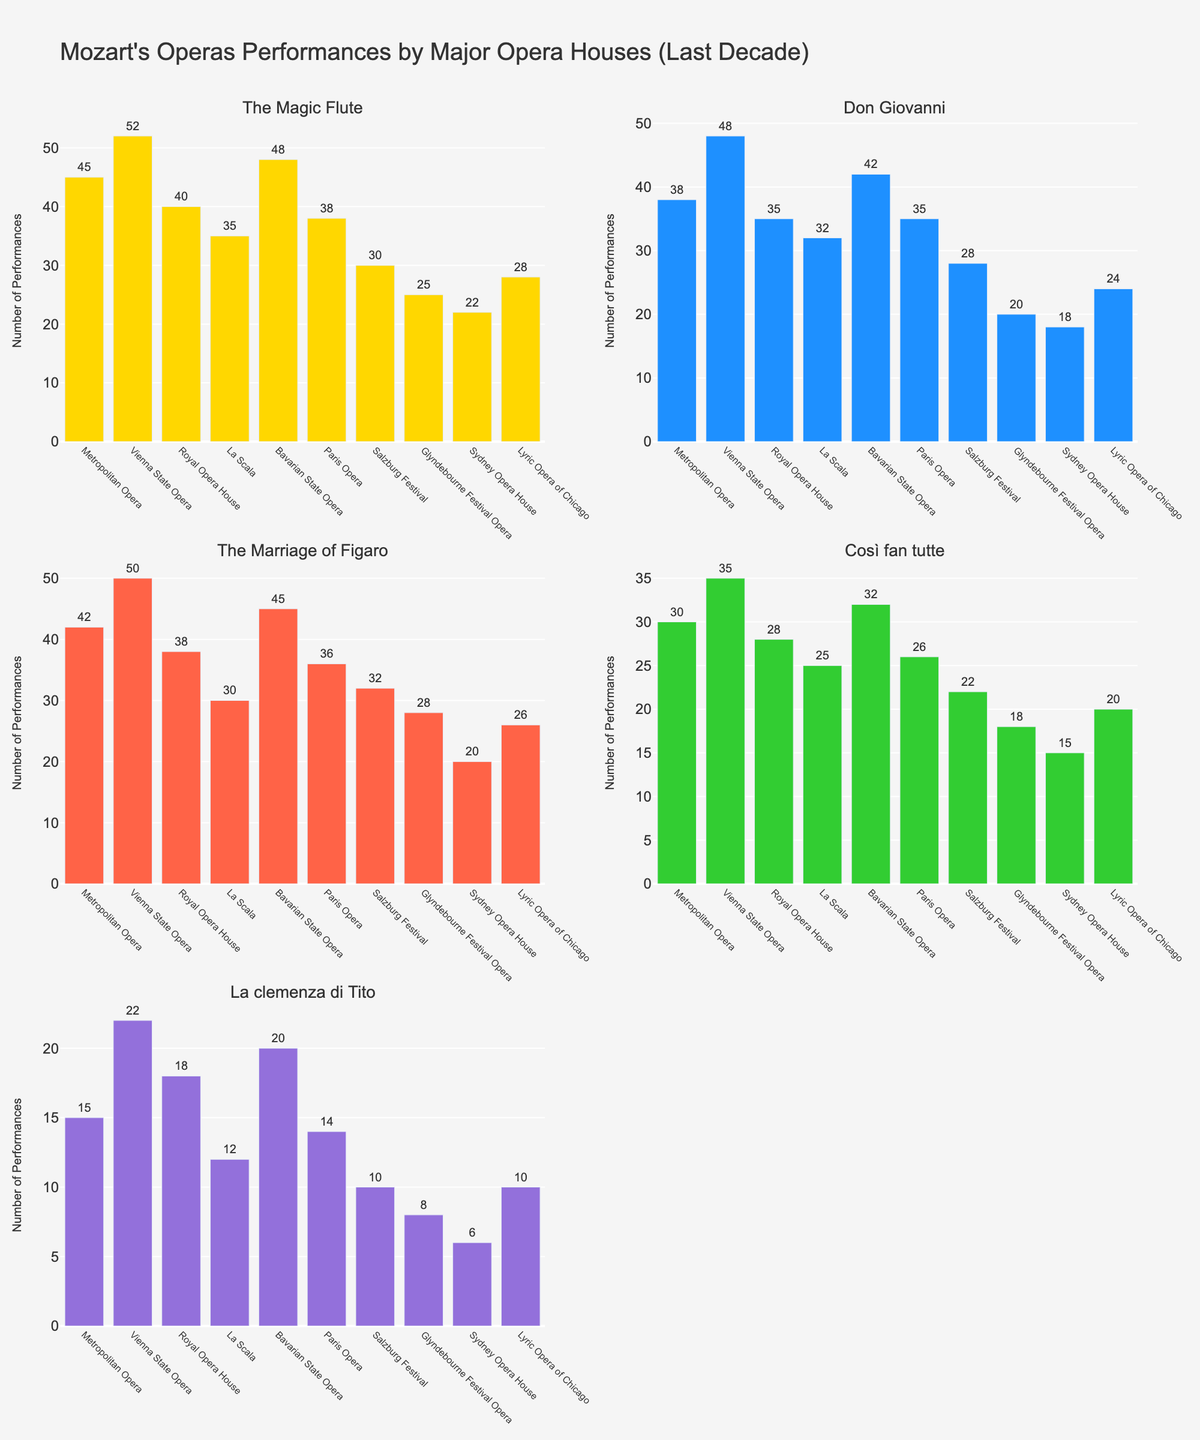What is the title of the figure? The title usually appears at the top of the figure and summarizes what the figure is about. Here, it indicates that the plot shows Mozart's opera performances by major opera houses in the last decade.
Answer: "Mozart's Operas Performances by Major Opera Houses (Last Decade)" How many subplots are shown in the figure? By counting the individual plot areas within the entire figure, you can see there are a specific number of partitions. In this case, there are distinct sections for each opera.
Answer: 5 Which opera house has the most performances of "The Magic Flute"? Look at the bar heights for "The Magic Flute" subplot and find the highest bar. The label below the tallest bar indicates the opera house.
Answer: Vienna State Opera How many performances of "La clemenza di Tito" did the Glyndebourne Festival Opera have? Find the Glyndebourne Festival Opera bar in the "La clemenza di Tito" subplot and read its height or text.
Answer: 8 Which opera has the least number of performances at the La Scala? Within the La Scala row across all subplots, find the smallest among all their bars.
Answer: La clemenza di Tito Which opera house had more performances of "Don Giovanni", Metropolitan Opera or Paris Opera? Compare the bar heights for the Metropolitan Opera and Paris Opera in the "Don Giovanni" subplot.
Answer: Metropolitan Opera What is the total number of performances of "Così fan tutte" across all opera houses? Sum all the heights or text values of the bars in the "Così fan tutte" subplot.
Answer: 251 What is the difference in the number of performances of "The Marriage of Figaro" between the Bavarian State Opera and the Sydney Opera House? Subtract the height or text value of the Sydney Opera House bar from the height or text value of the Bavarian State Opera bar in the "The Marriage of Figaro" subplot.
Answer: 25 Which opera has the highest average number of performances across all opera houses? Calculate the average for each opera by summing the performances across all opera houses and dividing by the number of opera houses, then compare these averages.
Answer: The Magic Flute What is the relationship between the total number of performances of "Don Giovanni" and "La clemenza di Tito" at the Vienna State Opera? Compare the height or text value of the Vienna State Opera bar in the "Don Giovanni" subplot to the one in the "La clemenza di Tito" subplot.
Answer: "Don Giovanni" has more performances 